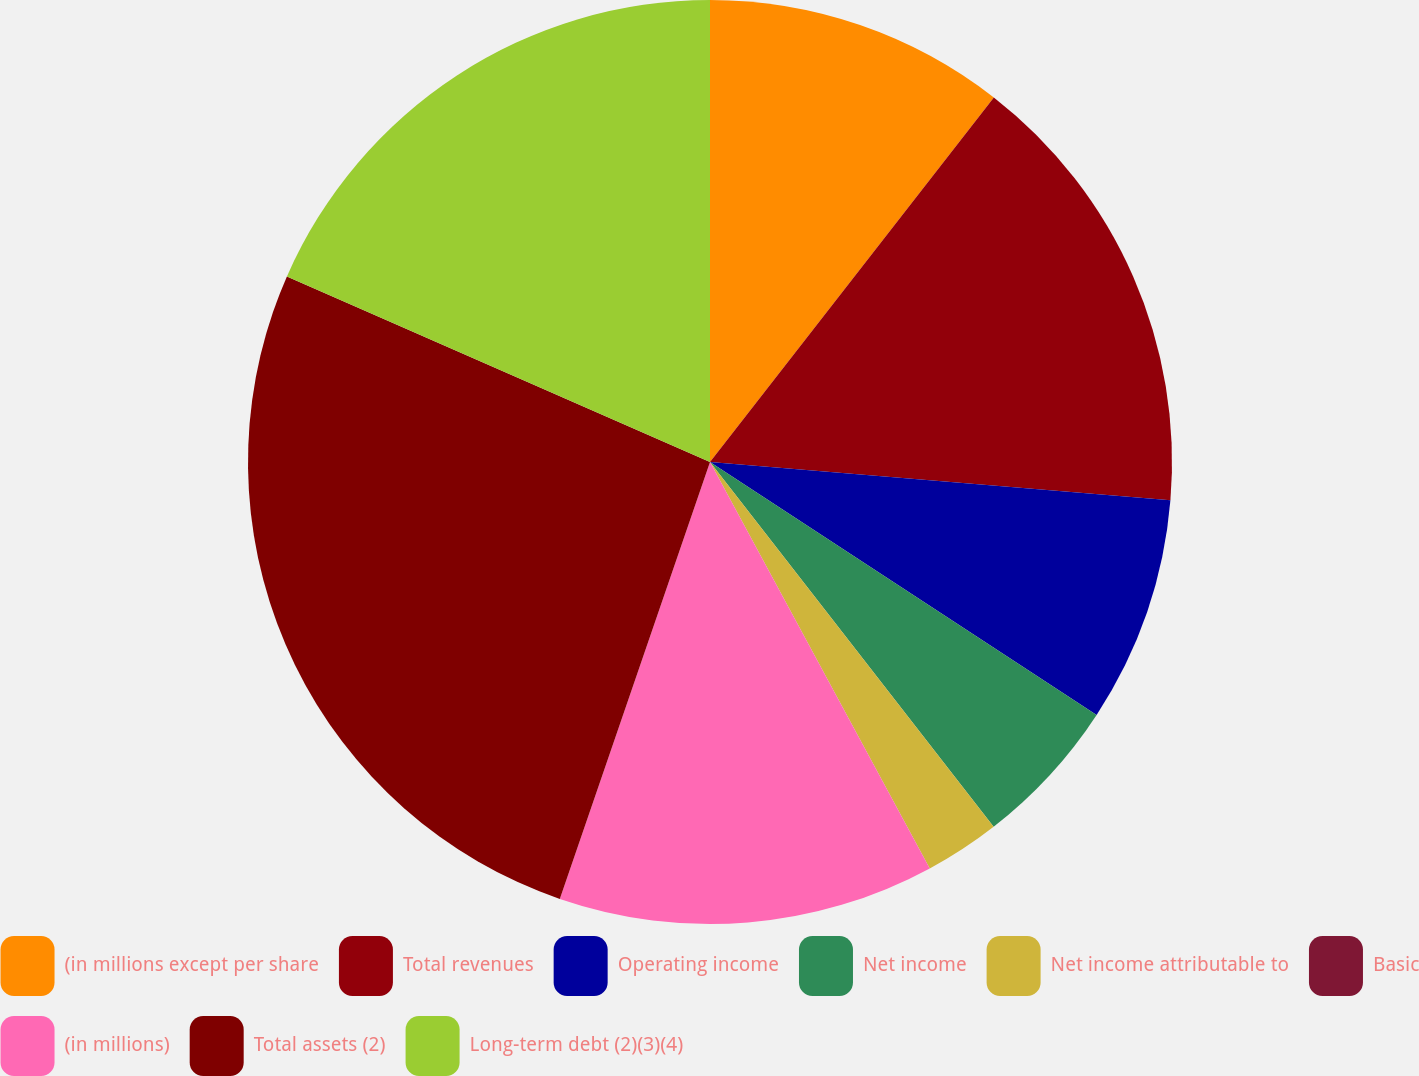<chart> <loc_0><loc_0><loc_500><loc_500><pie_chart><fcel>(in millions except per share<fcel>Total revenues<fcel>Operating income<fcel>Net income<fcel>Net income attributable to<fcel>Basic<fcel>(in millions)<fcel>Total assets (2)<fcel>Long-term debt (2)(3)(4)<nl><fcel>10.53%<fcel>15.79%<fcel>7.9%<fcel>5.26%<fcel>2.63%<fcel>0.0%<fcel>13.16%<fcel>26.31%<fcel>18.42%<nl></chart> 